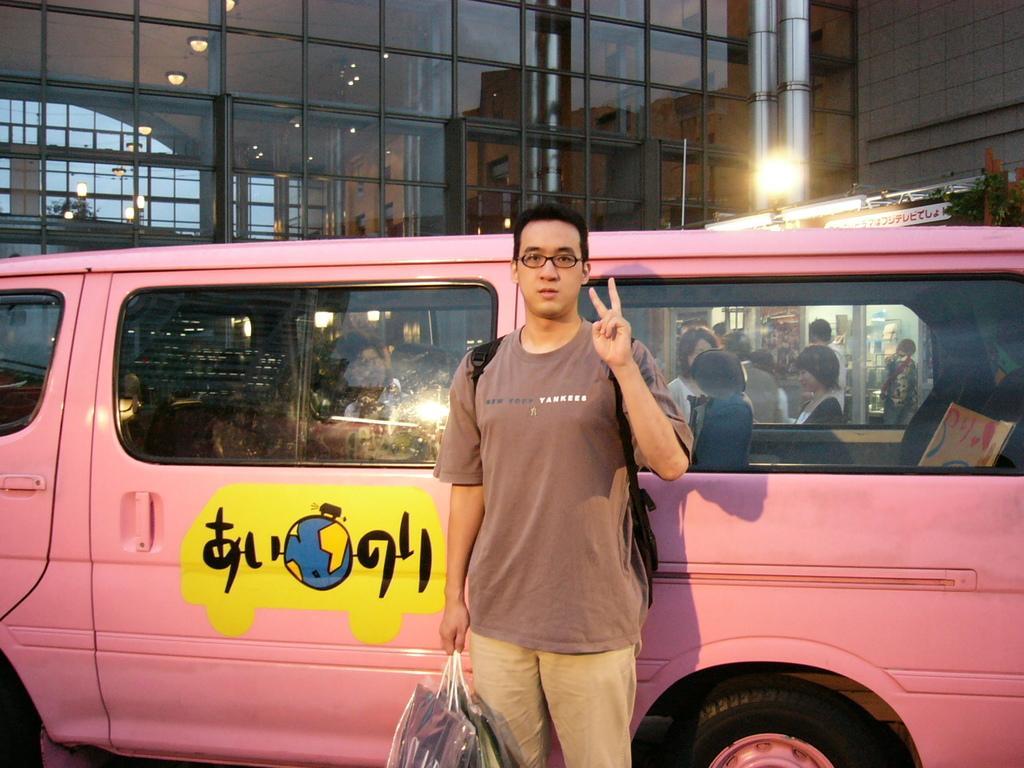Please provide a concise description of this image. In this picture we can see a man is holding some objects and standing on the path and behind the man there is a pink vehicle and behind the vehicle there are groups of people standing, building and in the building we can see there are ceiling lights on the top. 